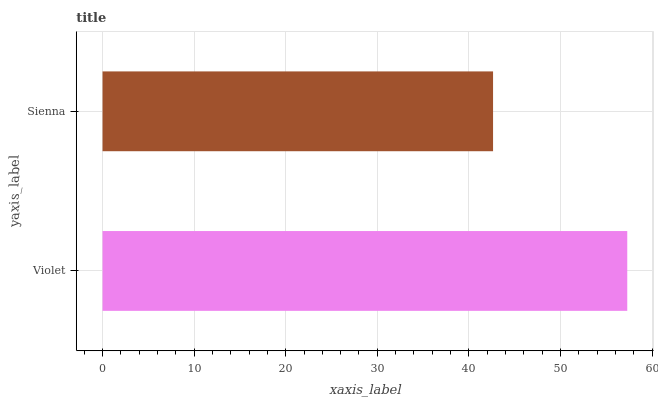Is Sienna the minimum?
Answer yes or no. Yes. Is Violet the maximum?
Answer yes or no. Yes. Is Sienna the maximum?
Answer yes or no. No. Is Violet greater than Sienna?
Answer yes or no. Yes. Is Sienna less than Violet?
Answer yes or no. Yes. Is Sienna greater than Violet?
Answer yes or no. No. Is Violet less than Sienna?
Answer yes or no. No. Is Violet the high median?
Answer yes or no. Yes. Is Sienna the low median?
Answer yes or no. Yes. Is Sienna the high median?
Answer yes or no. No. Is Violet the low median?
Answer yes or no. No. 